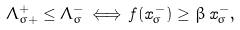Convert formula to latex. <formula><loc_0><loc_0><loc_500><loc_500>\Lambda _ { \sigma + } ^ { + } \leq \Lambda _ { \sigma } ^ { - } \, \Longleftrightarrow \, f ( x _ { \sigma } ^ { - } ) \geq \beta \, x _ { \sigma } ^ { - } ,</formula> 